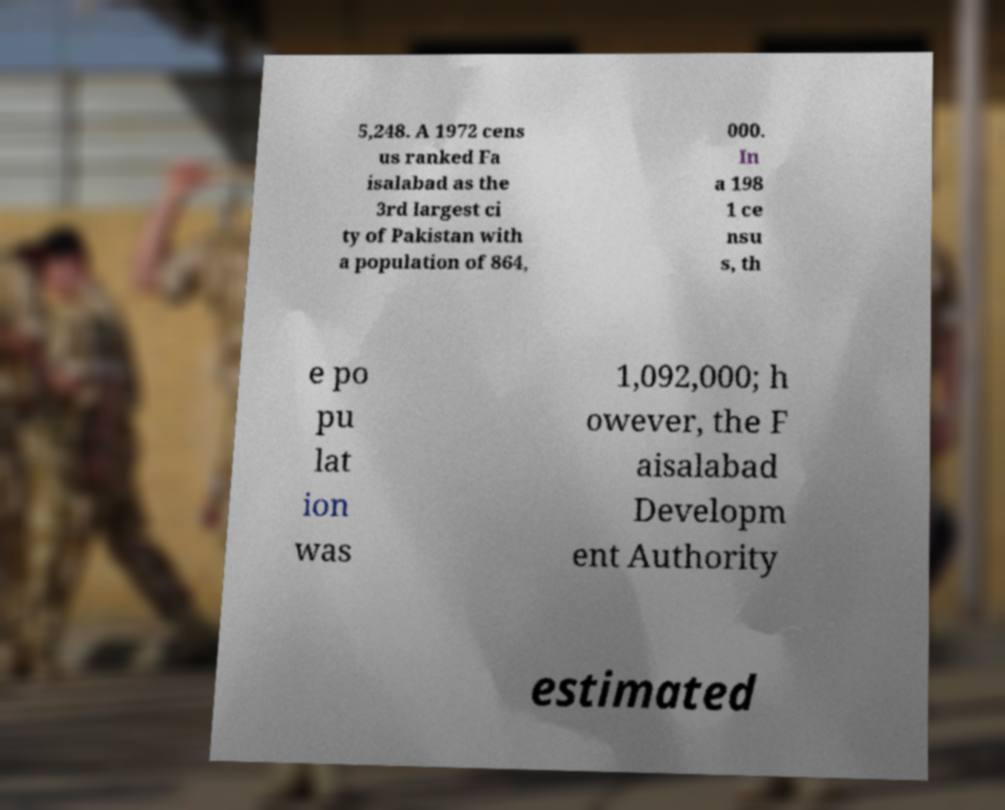Please read and relay the text visible in this image. What does it say? 5,248. A 1972 cens us ranked Fa isalabad as the 3rd largest ci ty of Pakistan with a population of 864, 000. In a 198 1 ce nsu s, th e po pu lat ion was 1,092,000; h owever, the F aisalabad Developm ent Authority estimated 